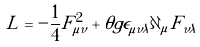<formula> <loc_0><loc_0><loc_500><loc_500>L = - \frac { 1 } { 4 } F _ { \mu \nu } ^ { 2 } + \theta g \epsilon _ { \mu \nu \lambda } \partial _ { \mu } F _ { \nu \lambda }</formula> 